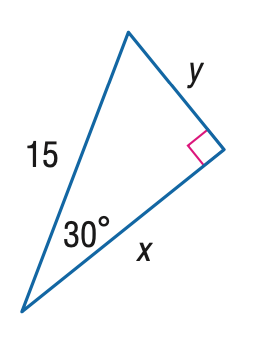Answer the mathemtical geometry problem and directly provide the correct option letter.
Question: Find x.
Choices: A: \frac { 15 } { 2 } B: \frac { 15 } { 2 } \sqrt { 2 } C: \frac { 15 } { 2 } \sqrt { 3 } D: 15 \sqrt { 3 } C 